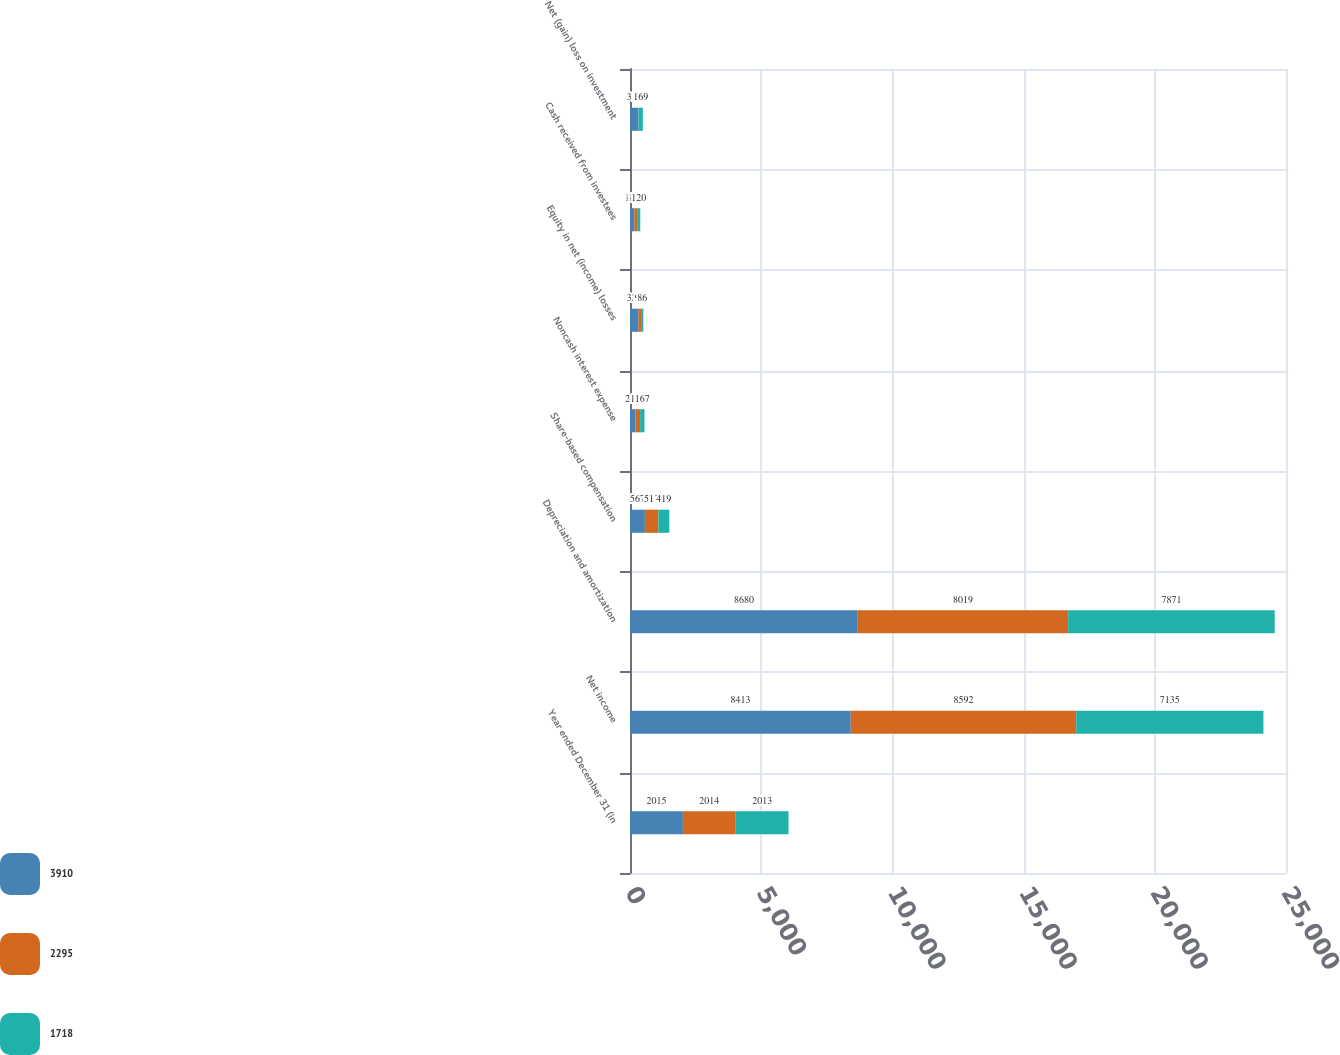Convert chart to OTSL. <chart><loc_0><loc_0><loc_500><loc_500><stacked_bar_chart><ecel><fcel>Year ended December 31 (in<fcel>Net income<fcel>Depreciation and amortization<fcel>Share-based compensation<fcel>Noncash interest expense<fcel>Equity in net (income) losses<fcel>Cash received from investees<fcel>Net (gain) loss on investment<nl><fcel>3910<fcel>2015<fcel>8413<fcel>8680<fcel>567<fcel>205<fcel>325<fcel>168<fcel>318<nl><fcel>2295<fcel>2014<fcel>8592<fcel>8019<fcel>513<fcel>180<fcel>97<fcel>104<fcel>4<nl><fcel>1718<fcel>2013<fcel>7135<fcel>7871<fcel>419<fcel>167<fcel>86<fcel>120<fcel>169<nl></chart> 